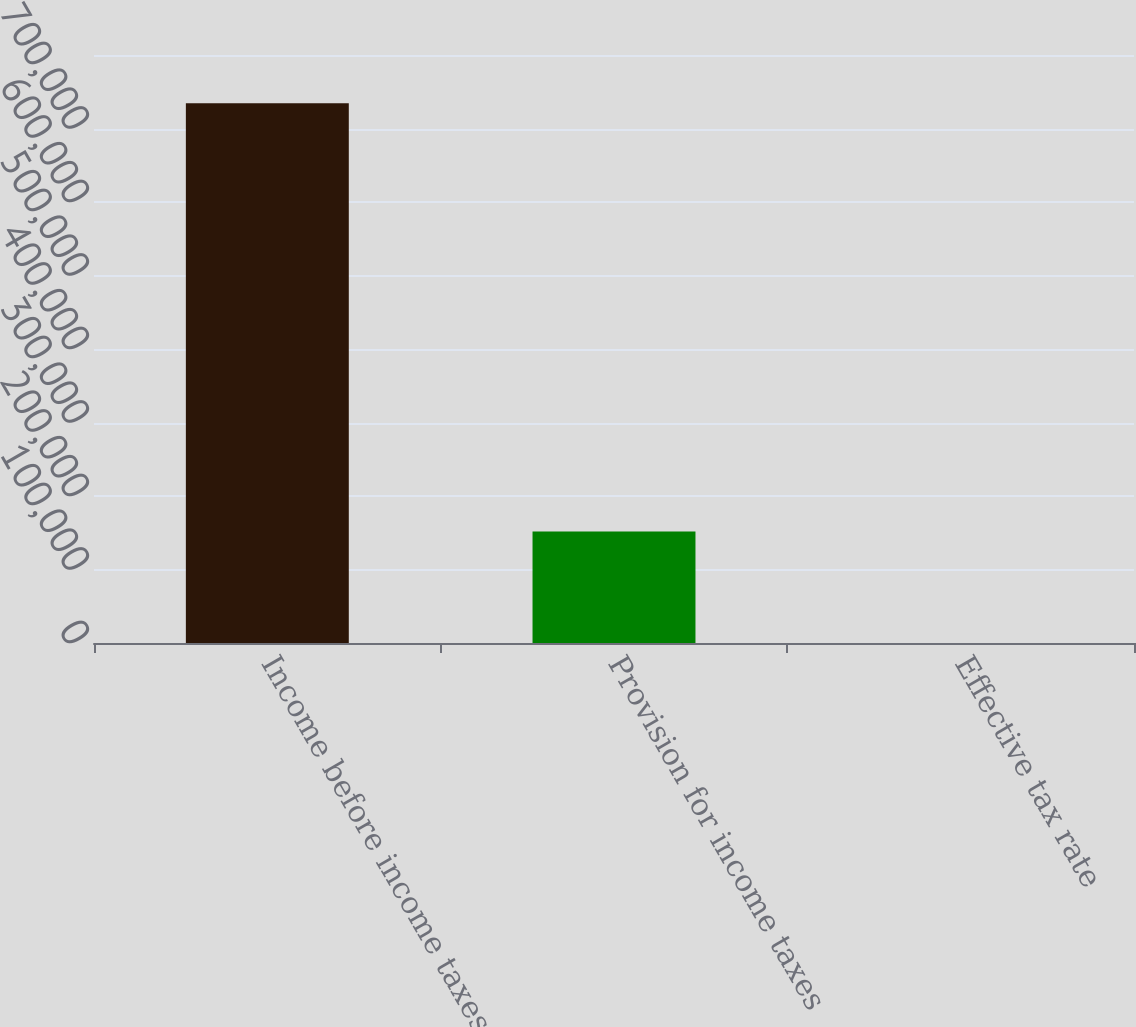Convert chart. <chart><loc_0><loc_0><loc_500><loc_500><bar_chart><fcel>Income before income taxes<fcel>Provision for income taxes<fcel>Effective tax rate<nl><fcel>734461<fcel>151706<fcel>20.7<nl></chart> 